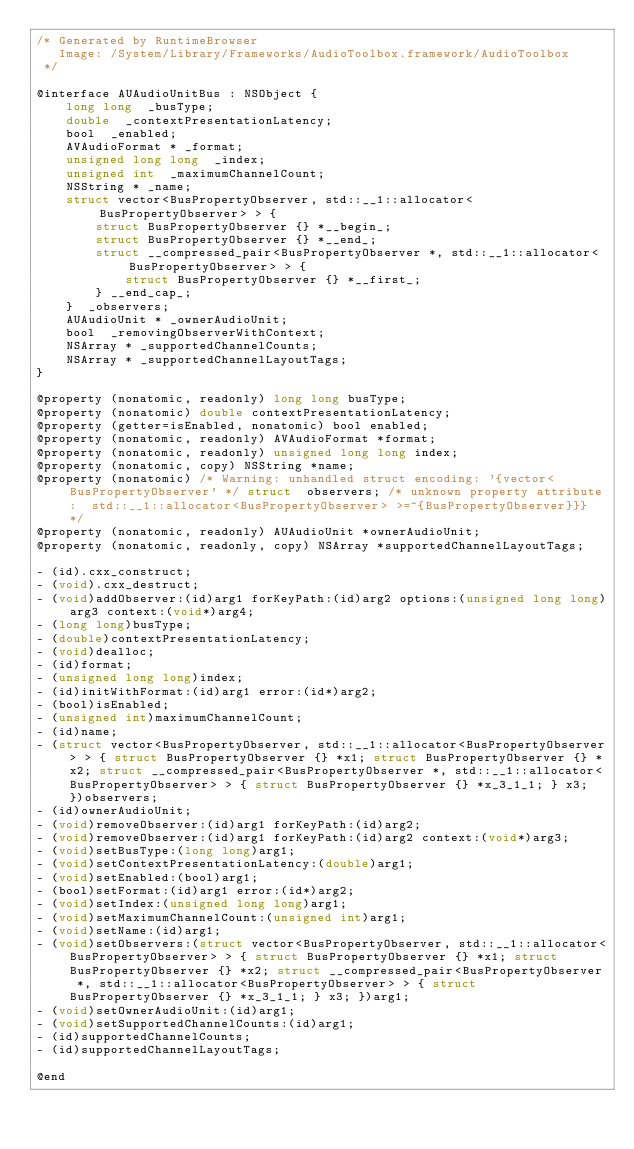<code> <loc_0><loc_0><loc_500><loc_500><_C_>/* Generated by RuntimeBrowser
   Image: /System/Library/Frameworks/AudioToolbox.framework/AudioToolbox
 */

@interface AUAudioUnitBus : NSObject {
    long long  _busType;
    double  _contextPresentationLatency;
    bool  _enabled;
    AVAudioFormat * _format;
    unsigned long long  _index;
    unsigned int  _maximumChannelCount;
    NSString * _name;
    struct vector<BusPropertyObserver, std::__1::allocator<BusPropertyObserver> > { 
        struct BusPropertyObserver {} *__begin_; 
        struct BusPropertyObserver {} *__end_; 
        struct __compressed_pair<BusPropertyObserver *, std::__1::allocator<BusPropertyObserver> > { 
            struct BusPropertyObserver {} *__first_; 
        } __end_cap_; 
    }  _observers;
    AUAudioUnit * _ownerAudioUnit;
    bool  _removingObserverWithContext;
    NSArray * _supportedChannelCounts;
    NSArray * _supportedChannelLayoutTags;
}

@property (nonatomic, readonly) long long busType;
@property (nonatomic) double contextPresentationLatency;
@property (getter=isEnabled, nonatomic) bool enabled;
@property (nonatomic, readonly) AVAudioFormat *format;
@property (nonatomic, readonly) unsigned long long index;
@property (nonatomic, copy) NSString *name;
@property (nonatomic) /* Warning: unhandled struct encoding: '{vector<BusPropertyObserver' */ struct  observers; /* unknown property attribute:  std::__1::allocator<BusPropertyObserver> >=^{BusPropertyObserver}}} */
@property (nonatomic, readonly) AUAudioUnit *ownerAudioUnit;
@property (nonatomic, readonly, copy) NSArray *supportedChannelLayoutTags;

- (id).cxx_construct;
- (void).cxx_destruct;
- (void)addObserver:(id)arg1 forKeyPath:(id)arg2 options:(unsigned long long)arg3 context:(void*)arg4;
- (long long)busType;
- (double)contextPresentationLatency;
- (void)dealloc;
- (id)format;
- (unsigned long long)index;
- (id)initWithFormat:(id)arg1 error:(id*)arg2;
- (bool)isEnabled;
- (unsigned int)maximumChannelCount;
- (id)name;
- (struct vector<BusPropertyObserver, std::__1::allocator<BusPropertyObserver> > { struct BusPropertyObserver {} *x1; struct BusPropertyObserver {} *x2; struct __compressed_pair<BusPropertyObserver *, std::__1::allocator<BusPropertyObserver> > { struct BusPropertyObserver {} *x_3_1_1; } x3; })observers;
- (id)ownerAudioUnit;
- (void)removeObserver:(id)arg1 forKeyPath:(id)arg2;
- (void)removeObserver:(id)arg1 forKeyPath:(id)arg2 context:(void*)arg3;
- (void)setBusType:(long long)arg1;
- (void)setContextPresentationLatency:(double)arg1;
- (void)setEnabled:(bool)arg1;
- (bool)setFormat:(id)arg1 error:(id*)arg2;
- (void)setIndex:(unsigned long long)arg1;
- (void)setMaximumChannelCount:(unsigned int)arg1;
- (void)setName:(id)arg1;
- (void)setObservers:(struct vector<BusPropertyObserver, std::__1::allocator<BusPropertyObserver> > { struct BusPropertyObserver {} *x1; struct BusPropertyObserver {} *x2; struct __compressed_pair<BusPropertyObserver *, std::__1::allocator<BusPropertyObserver> > { struct BusPropertyObserver {} *x_3_1_1; } x3; })arg1;
- (void)setOwnerAudioUnit:(id)arg1;
- (void)setSupportedChannelCounts:(id)arg1;
- (id)supportedChannelCounts;
- (id)supportedChannelLayoutTags;

@end
</code> 